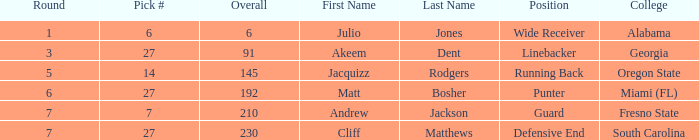Which highest pick number had Akeem Dent as a name and where the overall was less than 91? None. 